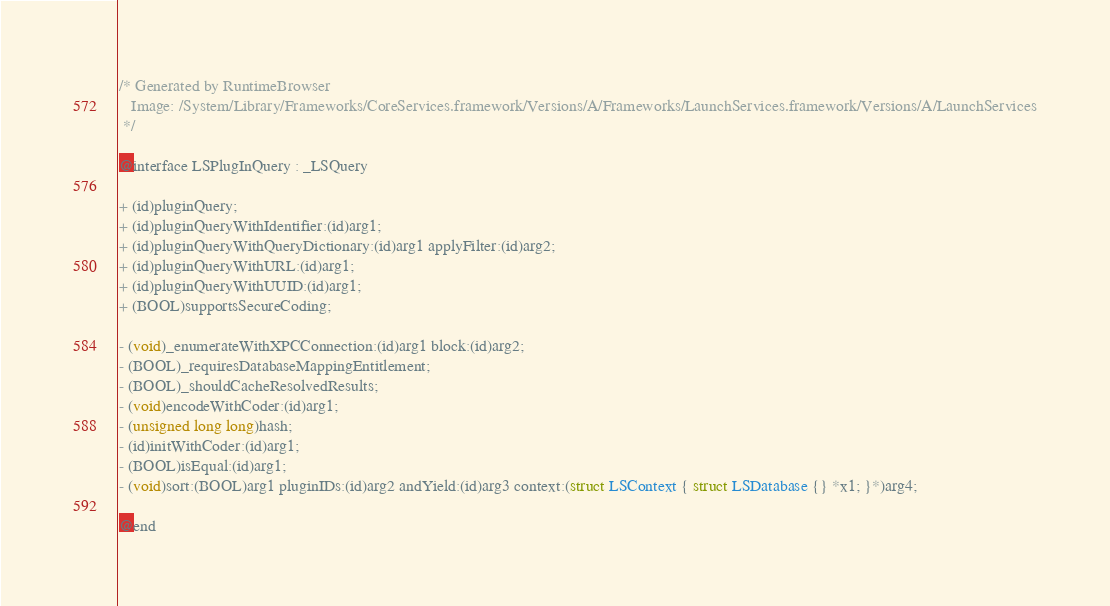<code> <loc_0><loc_0><loc_500><loc_500><_C_>/* Generated by RuntimeBrowser
   Image: /System/Library/Frameworks/CoreServices.framework/Versions/A/Frameworks/LaunchServices.framework/Versions/A/LaunchServices
 */

@interface LSPlugInQuery : _LSQuery

+ (id)pluginQuery;
+ (id)pluginQueryWithIdentifier:(id)arg1;
+ (id)pluginQueryWithQueryDictionary:(id)arg1 applyFilter:(id)arg2;
+ (id)pluginQueryWithURL:(id)arg1;
+ (id)pluginQueryWithUUID:(id)arg1;
+ (BOOL)supportsSecureCoding;

- (void)_enumerateWithXPCConnection:(id)arg1 block:(id)arg2;
- (BOOL)_requiresDatabaseMappingEntitlement;
- (BOOL)_shouldCacheResolvedResults;
- (void)encodeWithCoder:(id)arg1;
- (unsigned long long)hash;
- (id)initWithCoder:(id)arg1;
- (BOOL)isEqual:(id)arg1;
- (void)sort:(BOOL)arg1 pluginIDs:(id)arg2 andYield:(id)arg3 context:(struct LSContext { struct LSDatabase {} *x1; }*)arg4;

@end
</code> 